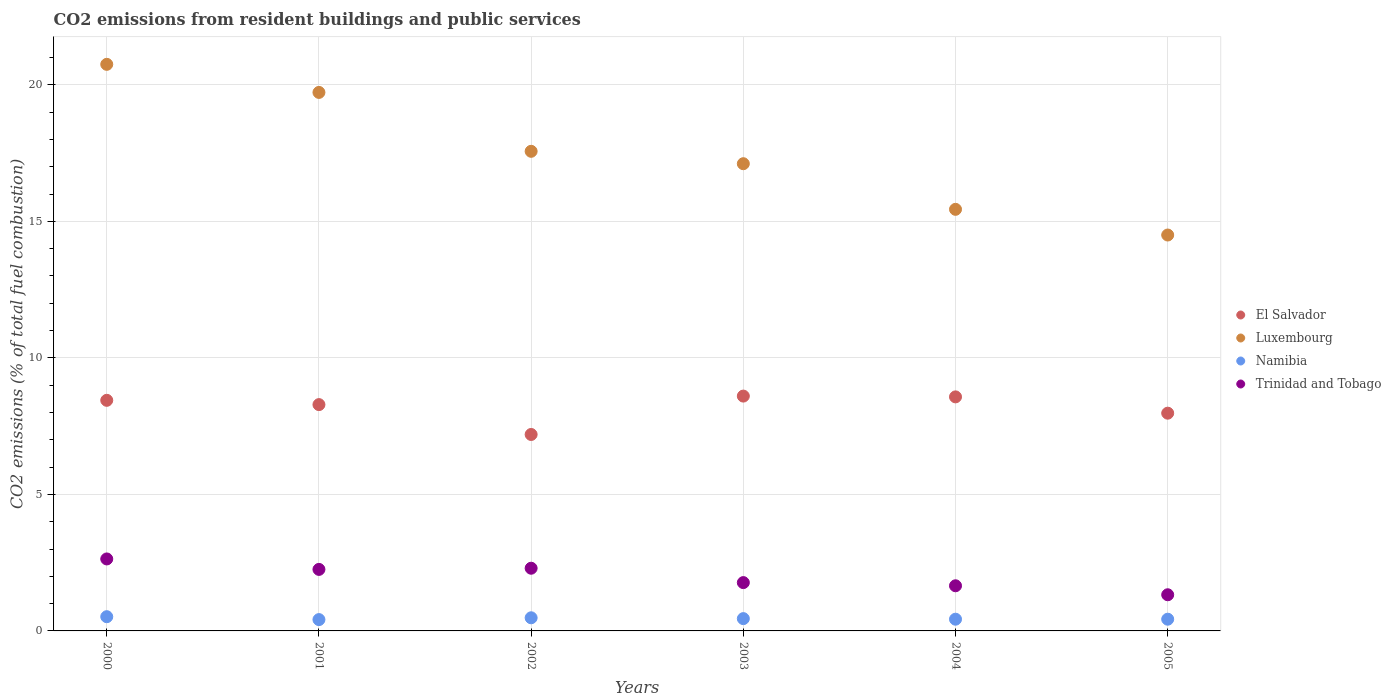How many different coloured dotlines are there?
Ensure brevity in your answer.  4. What is the total CO2 emitted in El Salvador in 2003?
Your answer should be compact. 8.6. Across all years, what is the maximum total CO2 emitted in Namibia?
Make the answer very short. 0.52. Across all years, what is the minimum total CO2 emitted in Luxembourg?
Offer a terse response. 14.5. In which year was the total CO2 emitted in Trinidad and Tobago maximum?
Your response must be concise. 2000. What is the total total CO2 emitted in El Salvador in the graph?
Provide a succinct answer. 49.07. What is the difference between the total CO2 emitted in Namibia in 2001 and that in 2002?
Offer a very short reply. -0.07. What is the difference between the total CO2 emitted in El Salvador in 2004 and the total CO2 emitted in Namibia in 2001?
Your answer should be compact. 8.16. What is the average total CO2 emitted in Trinidad and Tobago per year?
Ensure brevity in your answer.  1.99. In the year 2005, what is the difference between the total CO2 emitted in Trinidad and Tobago and total CO2 emitted in Luxembourg?
Offer a very short reply. -13.17. What is the ratio of the total CO2 emitted in Trinidad and Tobago in 2004 to that in 2005?
Your answer should be very brief. 1.25. Is the total CO2 emitted in El Salvador in 2000 less than that in 2004?
Provide a succinct answer. Yes. What is the difference between the highest and the second highest total CO2 emitted in Namibia?
Your answer should be very brief. 0.04. What is the difference between the highest and the lowest total CO2 emitted in Namibia?
Ensure brevity in your answer.  0.11. Is the sum of the total CO2 emitted in Trinidad and Tobago in 2000 and 2001 greater than the maximum total CO2 emitted in El Salvador across all years?
Keep it short and to the point. No. Is the total CO2 emitted in Namibia strictly greater than the total CO2 emitted in El Salvador over the years?
Make the answer very short. No. How many dotlines are there?
Provide a short and direct response. 4. What is the difference between two consecutive major ticks on the Y-axis?
Provide a short and direct response. 5. Where does the legend appear in the graph?
Ensure brevity in your answer.  Center right. How are the legend labels stacked?
Keep it short and to the point. Vertical. What is the title of the graph?
Ensure brevity in your answer.  CO2 emissions from resident buildings and public services. What is the label or title of the X-axis?
Provide a short and direct response. Years. What is the label or title of the Y-axis?
Your response must be concise. CO2 emissions (% of total fuel combustion). What is the CO2 emissions (% of total fuel combustion) of El Salvador in 2000?
Provide a succinct answer. 8.45. What is the CO2 emissions (% of total fuel combustion) in Luxembourg in 2000?
Your response must be concise. 20.75. What is the CO2 emissions (% of total fuel combustion) in Namibia in 2000?
Give a very brief answer. 0.52. What is the CO2 emissions (% of total fuel combustion) in Trinidad and Tobago in 2000?
Your answer should be compact. 2.64. What is the CO2 emissions (% of total fuel combustion) in El Salvador in 2001?
Your response must be concise. 8.29. What is the CO2 emissions (% of total fuel combustion) of Luxembourg in 2001?
Your response must be concise. 19.72. What is the CO2 emissions (% of total fuel combustion) in Namibia in 2001?
Make the answer very short. 0.41. What is the CO2 emissions (% of total fuel combustion) in Trinidad and Tobago in 2001?
Your response must be concise. 2.25. What is the CO2 emissions (% of total fuel combustion) of El Salvador in 2002?
Offer a terse response. 7.19. What is the CO2 emissions (% of total fuel combustion) in Luxembourg in 2002?
Your answer should be compact. 17.56. What is the CO2 emissions (% of total fuel combustion) of Namibia in 2002?
Ensure brevity in your answer.  0.48. What is the CO2 emissions (% of total fuel combustion) in Trinidad and Tobago in 2002?
Give a very brief answer. 2.3. What is the CO2 emissions (% of total fuel combustion) in El Salvador in 2003?
Your answer should be compact. 8.6. What is the CO2 emissions (% of total fuel combustion) of Luxembourg in 2003?
Your response must be concise. 17.11. What is the CO2 emissions (% of total fuel combustion) in Namibia in 2003?
Provide a short and direct response. 0.45. What is the CO2 emissions (% of total fuel combustion) of Trinidad and Tobago in 2003?
Provide a succinct answer. 1.77. What is the CO2 emissions (% of total fuel combustion) of El Salvador in 2004?
Your answer should be compact. 8.57. What is the CO2 emissions (% of total fuel combustion) of Luxembourg in 2004?
Make the answer very short. 15.44. What is the CO2 emissions (% of total fuel combustion) of Namibia in 2004?
Provide a short and direct response. 0.43. What is the CO2 emissions (% of total fuel combustion) of Trinidad and Tobago in 2004?
Offer a very short reply. 1.65. What is the CO2 emissions (% of total fuel combustion) in El Salvador in 2005?
Ensure brevity in your answer.  7.97. What is the CO2 emissions (% of total fuel combustion) of Luxembourg in 2005?
Your response must be concise. 14.5. What is the CO2 emissions (% of total fuel combustion) of Namibia in 2005?
Provide a short and direct response. 0.43. What is the CO2 emissions (% of total fuel combustion) in Trinidad and Tobago in 2005?
Ensure brevity in your answer.  1.32. Across all years, what is the maximum CO2 emissions (% of total fuel combustion) in El Salvador?
Provide a succinct answer. 8.6. Across all years, what is the maximum CO2 emissions (% of total fuel combustion) of Luxembourg?
Make the answer very short. 20.75. Across all years, what is the maximum CO2 emissions (% of total fuel combustion) of Namibia?
Your response must be concise. 0.52. Across all years, what is the maximum CO2 emissions (% of total fuel combustion) in Trinidad and Tobago?
Keep it short and to the point. 2.64. Across all years, what is the minimum CO2 emissions (% of total fuel combustion) of El Salvador?
Your response must be concise. 7.19. Across all years, what is the minimum CO2 emissions (% of total fuel combustion) of Luxembourg?
Your response must be concise. 14.5. Across all years, what is the minimum CO2 emissions (% of total fuel combustion) in Namibia?
Provide a succinct answer. 0.41. Across all years, what is the minimum CO2 emissions (% of total fuel combustion) in Trinidad and Tobago?
Give a very brief answer. 1.32. What is the total CO2 emissions (% of total fuel combustion) of El Salvador in the graph?
Ensure brevity in your answer.  49.07. What is the total CO2 emissions (% of total fuel combustion) in Luxembourg in the graph?
Offer a very short reply. 105.09. What is the total CO2 emissions (% of total fuel combustion) of Namibia in the graph?
Ensure brevity in your answer.  2.73. What is the total CO2 emissions (% of total fuel combustion) of Trinidad and Tobago in the graph?
Give a very brief answer. 11.93. What is the difference between the CO2 emissions (% of total fuel combustion) in El Salvador in 2000 and that in 2001?
Your answer should be very brief. 0.16. What is the difference between the CO2 emissions (% of total fuel combustion) of Luxembourg in 2000 and that in 2001?
Your response must be concise. 1.03. What is the difference between the CO2 emissions (% of total fuel combustion) of Namibia in 2000 and that in 2001?
Ensure brevity in your answer.  0.11. What is the difference between the CO2 emissions (% of total fuel combustion) in Trinidad and Tobago in 2000 and that in 2001?
Your answer should be very brief. 0.38. What is the difference between the CO2 emissions (% of total fuel combustion) in El Salvador in 2000 and that in 2002?
Your answer should be compact. 1.25. What is the difference between the CO2 emissions (% of total fuel combustion) of Luxembourg in 2000 and that in 2002?
Keep it short and to the point. 3.19. What is the difference between the CO2 emissions (% of total fuel combustion) in Namibia in 2000 and that in 2002?
Your response must be concise. 0.04. What is the difference between the CO2 emissions (% of total fuel combustion) in Trinidad and Tobago in 2000 and that in 2002?
Offer a terse response. 0.34. What is the difference between the CO2 emissions (% of total fuel combustion) of El Salvador in 2000 and that in 2003?
Your answer should be compact. -0.15. What is the difference between the CO2 emissions (% of total fuel combustion) in Luxembourg in 2000 and that in 2003?
Offer a very short reply. 3.64. What is the difference between the CO2 emissions (% of total fuel combustion) of Namibia in 2000 and that in 2003?
Offer a very short reply. 0.07. What is the difference between the CO2 emissions (% of total fuel combustion) in Trinidad and Tobago in 2000 and that in 2003?
Give a very brief answer. 0.87. What is the difference between the CO2 emissions (% of total fuel combustion) of El Salvador in 2000 and that in 2004?
Your response must be concise. -0.13. What is the difference between the CO2 emissions (% of total fuel combustion) in Luxembourg in 2000 and that in 2004?
Keep it short and to the point. 5.31. What is the difference between the CO2 emissions (% of total fuel combustion) in Namibia in 2000 and that in 2004?
Your response must be concise. 0.09. What is the difference between the CO2 emissions (% of total fuel combustion) in Trinidad and Tobago in 2000 and that in 2004?
Offer a terse response. 0.98. What is the difference between the CO2 emissions (% of total fuel combustion) of El Salvador in 2000 and that in 2005?
Offer a very short reply. 0.47. What is the difference between the CO2 emissions (% of total fuel combustion) in Luxembourg in 2000 and that in 2005?
Keep it short and to the point. 6.25. What is the difference between the CO2 emissions (% of total fuel combustion) of Namibia in 2000 and that in 2005?
Give a very brief answer. 0.09. What is the difference between the CO2 emissions (% of total fuel combustion) in Trinidad and Tobago in 2000 and that in 2005?
Provide a succinct answer. 1.31. What is the difference between the CO2 emissions (% of total fuel combustion) of El Salvador in 2001 and that in 2002?
Provide a short and direct response. 1.09. What is the difference between the CO2 emissions (% of total fuel combustion) in Luxembourg in 2001 and that in 2002?
Give a very brief answer. 2.16. What is the difference between the CO2 emissions (% of total fuel combustion) of Namibia in 2001 and that in 2002?
Give a very brief answer. -0.07. What is the difference between the CO2 emissions (% of total fuel combustion) of Trinidad and Tobago in 2001 and that in 2002?
Provide a succinct answer. -0.04. What is the difference between the CO2 emissions (% of total fuel combustion) of El Salvador in 2001 and that in 2003?
Give a very brief answer. -0.31. What is the difference between the CO2 emissions (% of total fuel combustion) in Luxembourg in 2001 and that in 2003?
Provide a succinct answer. 2.61. What is the difference between the CO2 emissions (% of total fuel combustion) of Namibia in 2001 and that in 2003?
Make the answer very short. -0.04. What is the difference between the CO2 emissions (% of total fuel combustion) of Trinidad and Tobago in 2001 and that in 2003?
Keep it short and to the point. 0.48. What is the difference between the CO2 emissions (% of total fuel combustion) in El Salvador in 2001 and that in 2004?
Your answer should be compact. -0.28. What is the difference between the CO2 emissions (% of total fuel combustion) in Luxembourg in 2001 and that in 2004?
Offer a terse response. 4.28. What is the difference between the CO2 emissions (% of total fuel combustion) of Namibia in 2001 and that in 2004?
Your answer should be compact. -0.01. What is the difference between the CO2 emissions (% of total fuel combustion) of Trinidad and Tobago in 2001 and that in 2004?
Keep it short and to the point. 0.6. What is the difference between the CO2 emissions (% of total fuel combustion) of El Salvador in 2001 and that in 2005?
Your answer should be compact. 0.31. What is the difference between the CO2 emissions (% of total fuel combustion) in Luxembourg in 2001 and that in 2005?
Provide a short and direct response. 5.22. What is the difference between the CO2 emissions (% of total fuel combustion) in Namibia in 2001 and that in 2005?
Offer a very short reply. -0.01. What is the difference between the CO2 emissions (% of total fuel combustion) of Trinidad and Tobago in 2001 and that in 2005?
Keep it short and to the point. 0.93. What is the difference between the CO2 emissions (% of total fuel combustion) of El Salvador in 2002 and that in 2003?
Offer a terse response. -1.41. What is the difference between the CO2 emissions (% of total fuel combustion) of Luxembourg in 2002 and that in 2003?
Make the answer very short. 0.45. What is the difference between the CO2 emissions (% of total fuel combustion) of Namibia in 2002 and that in 2003?
Make the answer very short. 0.03. What is the difference between the CO2 emissions (% of total fuel combustion) in Trinidad and Tobago in 2002 and that in 2003?
Your answer should be compact. 0.53. What is the difference between the CO2 emissions (% of total fuel combustion) of El Salvador in 2002 and that in 2004?
Make the answer very short. -1.38. What is the difference between the CO2 emissions (% of total fuel combustion) of Luxembourg in 2002 and that in 2004?
Make the answer very short. 2.12. What is the difference between the CO2 emissions (% of total fuel combustion) in Namibia in 2002 and that in 2004?
Your response must be concise. 0.05. What is the difference between the CO2 emissions (% of total fuel combustion) of Trinidad and Tobago in 2002 and that in 2004?
Keep it short and to the point. 0.64. What is the difference between the CO2 emissions (% of total fuel combustion) in El Salvador in 2002 and that in 2005?
Offer a terse response. -0.78. What is the difference between the CO2 emissions (% of total fuel combustion) in Luxembourg in 2002 and that in 2005?
Provide a succinct answer. 3.07. What is the difference between the CO2 emissions (% of total fuel combustion) of Namibia in 2002 and that in 2005?
Ensure brevity in your answer.  0.05. What is the difference between the CO2 emissions (% of total fuel combustion) of Trinidad and Tobago in 2002 and that in 2005?
Give a very brief answer. 0.97. What is the difference between the CO2 emissions (% of total fuel combustion) in El Salvador in 2003 and that in 2004?
Provide a short and direct response. 0.03. What is the difference between the CO2 emissions (% of total fuel combustion) of Luxembourg in 2003 and that in 2004?
Give a very brief answer. 1.67. What is the difference between the CO2 emissions (% of total fuel combustion) in Namibia in 2003 and that in 2004?
Provide a succinct answer. 0.02. What is the difference between the CO2 emissions (% of total fuel combustion) of Trinidad and Tobago in 2003 and that in 2004?
Your answer should be very brief. 0.12. What is the difference between the CO2 emissions (% of total fuel combustion) in El Salvador in 2003 and that in 2005?
Give a very brief answer. 0.63. What is the difference between the CO2 emissions (% of total fuel combustion) of Luxembourg in 2003 and that in 2005?
Provide a short and direct response. 2.61. What is the difference between the CO2 emissions (% of total fuel combustion) in Namibia in 2003 and that in 2005?
Make the answer very short. 0.02. What is the difference between the CO2 emissions (% of total fuel combustion) in Trinidad and Tobago in 2003 and that in 2005?
Your response must be concise. 0.45. What is the difference between the CO2 emissions (% of total fuel combustion) in El Salvador in 2004 and that in 2005?
Offer a very short reply. 0.6. What is the difference between the CO2 emissions (% of total fuel combustion) in Luxembourg in 2004 and that in 2005?
Your response must be concise. 0.94. What is the difference between the CO2 emissions (% of total fuel combustion) in Namibia in 2004 and that in 2005?
Give a very brief answer. 0. What is the difference between the CO2 emissions (% of total fuel combustion) in Trinidad and Tobago in 2004 and that in 2005?
Provide a short and direct response. 0.33. What is the difference between the CO2 emissions (% of total fuel combustion) in El Salvador in 2000 and the CO2 emissions (% of total fuel combustion) in Luxembourg in 2001?
Your answer should be very brief. -11.28. What is the difference between the CO2 emissions (% of total fuel combustion) of El Salvador in 2000 and the CO2 emissions (% of total fuel combustion) of Namibia in 2001?
Ensure brevity in your answer.  8.03. What is the difference between the CO2 emissions (% of total fuel combustion) in El Salvador in 2000 and the CO2 emissions (% of total fuel combustion) in Trinidad and Tobago in 2001?
Give a very brief answer. 6.19. What is the difference between the CO2 emissions (% of total fuel combustion) in Luxembourg in 2000 and the CO2 emissions (% of total fuel combustion) in Namibia in 2001?
Provide a short and direct response. 20.34. What is the difference between the CO2 emissions (% of total fuel combustion) in Luxembourg in 2000 and the CO2 emissions (% of total fuel combustion) in Trinidad and Tobago in 2001?
Provide a succinct answer. 18.5. What is the difference between the CO2 emissions (% of total fuel combustion) of Namibia in 2000 and the CO2 emissions (% of total fuel combustion) of Trinidad and Tobago in 2001?
Your answer should be compact. -1.73. What is the difference between the CO2 emissions (% of total fuel combustion) of El Salvador in 2000 and the CO2 emissions (% of total fuel combustion) of Luxembourg in 2002?
Provide a succinct answer. -9.12. What is the difference between the CO2 emissions (% of total fuel combustion) of El Salvador in 2000 and the CO2 emissions (% of total fuel combustion) of Namibia in 2002?
Your answer should be very brief. 7.96. What is the difference between the CO2 emissions (% of total fuel combustion) in El Salvador in 2000 and the CO2 emissions (% of total fuel combustion) in Trinidad and Tobago in 2002?
Make the answer very short. 6.15. What is the difference between the CO2 emissions (% of total fuel combustion) in Luxembourg in 2000 and the CO2 emissions (% of total fuel combustion) in Namibia in 2002?
Make the answer very short. 20.27. What is the difference between the CO2 emissions (% of total fuel combustion) of Luxembourg in 2000 and the CO2 emissions (% of total fuel combustion) of Trinidad and Tobago in 2002?
Make the answer very short. 18.45. What is the difference between the CO2 emissions (% of total fuel combustion) in Namibia in 2000 and the CO2 emissions (% of total fuel combustion) in Trinidad and Tobago in 2002?
Offer a very short reply. -1.77. What is the difference between the CO2 emissions (% of total fuel combustion) in El Salvador in 2000 and the CO2 emissions (% of total fuel combustion) in Luxembourg in 2003?
Provide a succinct answer. -8.67. What is the difference between the CO2 emissions (% of total fuel combustion) of El Salvador in 2000 and the CO2 emissions (% of total fuel combustion) of Namibia in 2003?
Offer a terse response. 7.99. What is the difference between the CO2 emissions (% of total fuel combustion) of El Salvador in 2000 and the CO2 emissions (% of total fuel combustion) of Trinidad and Tobago in 2003?
Provide a short and direct response. 6.68. What is the difference between the CO2 emissions (% of total fuel combustion) of Luxembourg in 2000 and the CO2 emissions (% of total fuel combustion) of Namibia in 2003?
Make the answer very short. 20.3. What is the difference between the CO2 emissions (% of total fuel combustion) of Luxembourg in 2000 and the CO2 emissions (% of total fuel combustion) of Trinidad and Tobago in 2003?
Ensure brevity in your answer.  18.98. What is the difference between the CO2 emissions (% of total fuel combustion) in Namibia in 2000 and the CO2 emissions (% of total fuel combustion) in Trinidad and Tobago in 2003?
Your answer should be compact. -1.25. What is the difference between the CO2 emissions (% of total fuel combustion) in El Salvador in 2000 and the CO2 emissions (% of total fuel combustion) in Luxembourg in 2004?
Ensure brevity in your answer.  -6.99. What is the difference between the CO2 emissions (% of total fuel combustion) of El Salvador in 2000 and the CO2 emissions (% of total fuel combustion) of Namibia in 2004?
Your answer should be compact. 8.02. What is the difference between the CO2 emissions (% of total fuel combustion) of El Salvador in 2000 and the CO2 emissions (% of total fuel combustion) of Trinidad and Tobago in 2004?
Keep it short and to the point. 6.79. What is the difference between the CO2 emissions (% of total fuel combustion) of Luxembourg in 2000 and the CO2 emissions (% of total fuel combustion) of Namibia in 2004?
Your response must be concise. 20.32. What is the difference between the CO2 emissions (% of total fuel combustion) of Luxembourg in 2000 and the CO2 emissions (% of total fuel combustion) of Trinidad and Tobago in 2004?
Offer a very short reply. 19.1. What is the difference between the CO2 emissions (% of total fuel combustion) of Namibia in 2000 and the CO2 emissions (% of total fuel combustion) of Trinidad and Tobago in 2004?
Offer a terse response. -1.13. What is the difference between the CO2 emissions (% of total fuel combustion) of El Salvador in 2000 and the CO2 emissions (% of total fuel combustion) of Luxembourg in 2005?
Offer a very short reply. -6.05. What is the difference between the CO2 emissions (% of total fuel combustion) in El Salvador in 2000 and the CO2 emissions (% of total fuel combustion) in Namibia in 2005?
Give a very brief answer. 8.02. What is the difference between the CO2 emissions (% of total fuel combustion) of El Salvador in 2000 and the CO2 emissions (% of total fuel combustion) of Trinidad and Tobago in 2005?
Give a very brief answer. 7.12. What is the difference between the CO2 emissions (% of total fuel combustion) of Luxembourg in 2000 and the CO2 emissions (% of total fuel combustion) of Namibia in 2005?
Provide a short and direct response. 20.32. What is the difference between the CO2 emissions (% of total fuel combustion) of Luxembourg in 2000 and the CO2 emissions (% of total fuel combustion) of Trinidad and Tobago in 2005?
Your response must be concise. 19.43. What is the difference between the CO2 emissions (% of total fuel combustion) in Namibia in 2000 and the CO2 emissions (% of total fuel combustion) in Trinidad and Tobago in 2005?
Your answer should be compact. -0.8. What is the difference between the CO2 emissions (% of total fuel combustion) of El Salvador in 2001 and the CO2 emissions (% of total fuel combustion) of Luxembourg in 2002?
Offer a very short reply. -9.28. What is the difference between the CO2 emissions (% of total fuel combustion) in El Salvador in 2001 and the CO2 emissions (% of total fuel combustion) in Namibia in 2002?
Give a very brief answer. 7.81. What is the difference between the CO2 emissions (% of total fuel combustion) in El Salvador in 2001 and the CO2 emissions (% of total fuel combustion) in Trinidad and Tobago in 2002?
Ensure brevity in your answer.  5.99. What is the difference between the CO2 emissions (% of total fuel combustion) of Luxembourg in 2001 and the CO2 emissions (% of total fuel combustion) of Namibia in 2002?
Ensure brevity in your answer.  19.24. What is the difference between the CO2 emissions (% of total fuel combustion) of Luxembourg in 2001 and the CO2 emissions (% of total fuel combustion) of Trinidad and Tobago in 2002?
Make the answer very short. 17.43. What is the difference between the CO2 emissions (% of total fuel combustion) of Namibia in 2001 and the CO2 emissions (% of total fuel combustion) of Trinidad and Tobago in 2002?
Keep it short and to the point. -1.88. What is the difference between the CO2 emissions (% of total fuel combustion) in El Salvador in 2001 and the CO2 emissions (% of total fuel combustion) in Luxembourg in 2003?
Offer a very short reply. -8.82. What is the difference between the CO2 emissions (% of total fuel combustion) in El Salvador in 2001 and the CO2 emissions (% of total fuel combustion) in Namibia in 2003?
Offer a terse response. 7.84. What is the difference between the CO2 emissions (% of total fuel combustion) of El Salvador in 2001 and the CO2 emissions (% of total fuel combustion) of Trinidad and Tobago in 2003?
Offer a very short reply. 6.52. What is the difference between the CO2 emissions (% of total fuel combustion) in Luxembourg in 2001 and the CO2 emissions (% of total fuel combustion) in Namibia in 2003?
Your response must be concise. 19.27. What is the difference between the CO2 emissions (% of total fuel combustion) of Luxembourg in 2001 and the CO2 emissions (% of total fuel combustion) of Trinidad and Tobago in 2003?
Offer a terse response. 17.95. What is the difference between the CO2 emissions (% of total fuel combustion) of Namibia in 2001 and the CO2 emissions (% of total fuel combustion) of Trinidad and Tobago in 2003?
Offer a very short reply. -1.35. What is the difference between the CO2 emissions (% of total fuel combustion) in El Salvador in 2001 and the CO2 emissions (% of total fuel combustion) in Luxembourg in 2004?
Ensure brevity in your answer.  -7.15. What is the difference between the CO2 emissions (% of total fuel combustion) in El Salvador in 2001 and the CO2 emissions (% of total fuel combustion) in Namibia in 2004?
Provide a succinct answer. 7.86. What is the difference between the CO2 emissions (% of total fuel combustion) of El Salvador in 2001 and the CO2 emissions (% of total fuel combustion) of Trinidad and Tobago in 2004?
Offer a very short reply. 6.64. What is the difference between the CO2 emissions (% of total fuel combustion) of Luxembourg in 2001 and the CO2 emissions (% of total fuel combustion) of Namibia in 2004?
Provide a succinct answer. 19.29. What is the difference between the CO2 emissions (% of total fuel combustion) in Luxembourg in 2001 and the CO2 emissions (% of total fuel combustion) in Trinidad and Tobago in 2004?
Your answer should be compact. 18.07. What is the difference between the CO2 emissions (% of total fuel combustion) in Namibia in 2001 and the CO2 emissions (% of total fuel combustion) in Trinidad and Tobago in 2004?
Provide a succinct answer. -1.24. What is the difference between the CO2 emissions (% of total fuel combustion) of El Salvador in 2001 and the CO2 emissions (% of total fuel combustion) of Luxembourg in 2005?
Give a very brief answer. -6.21. What is the difference between the CO2 emissions (% of total fuel combustion) of El Salvador in 2001 and the CO2 emissions (% of total fuel combustion) of Namibia in 2005?
Your answer should be very brief. 7.86. What is the difference between the CO2 emissions (% of total fuel combustion) of El Salvador in 2001 and the CO2 emissions (% of total fuel combustion) of Trinidad and Tobago in 2005?
Provide a succinct answer. 6.96. What is the difference between the CO2 emissions (% of total fuel combustion) of Luxembourg in 2001 and the CO2 emissions (% of total fuel combustion) of Namibia in 2005?
Your answer should be very brief. 19.29. What is the difference between the CO2 emissions (% of total fuel combustion) in Luxembourg in 2001 and the CO2 emissions (% of total fuel combustion) in Trinidad and Tobago in 2005?
Offer a terse response. 18.4. What is the difference between the CO2 emissions (% of total fuel combustion) of Namibia in 2001 and the CO2 emissions (% of total fuel combustion) of Trinidad and Tobago in 2005?
Ensure brevity in your answer.  -0.91. What is the difference between the CO2 emissions (% of total fuel combustion) of El Salvador in 2002 and the CO2 emissions (% of total fuel combustion) of Luxembourg in 2003?
Offer a terse response. -9.92. What is the difference between the CO2 emissions (% of total fuel combustion) of El Salvador in 2002 and the CO2 emissions (% of total fuel combustion) of Namibia in 2003?
Keep it short and to the point. 6.74. What is the difference between the CO2 emissions (% of total fuel combustion) of El Salvador in 2002 and the CO2 emissions (% of total fuel combustion) of Trinidad and Tobago in 2003?
Your answer should be compact. 5.42. What is the difference between the CO2 emissions (% of total fuel combustion) of Luxembourg in 2002 and the CO2 emissions (% of total fuel combustion) of Namibia in 2003?
Offer a terse response. 17.11. What is the difference between the CO2 emissions (% of total fuel combustion) of Luxembourg in 2002 and the CO2 emissions (% of total fuel combustion) of Trinidad and Tobago in 2003?
Your answer should be very brief. 15.8. What is the difference between the CO2 emissions (% of total fuel combustion) in Namibia in 2002 and the CO2 emissions (% of total fuel combustion) in Trinidad and Tobago in 2003?
Offer a very short reply. -1.29. What is the difference between the CO2 emissions (% of total fuel combustion) of El Salvador in 2002 and the CO2 emissions (% of total fuel combustion) of Luxembourg in 2004?
Your response must be concise. -8.25. What is the difference between the CO2 emissions (% of total fuel combustion) in El Salvador in 2002 and the CO2 emissions (% of total fuel combustion) in Namibia in 2004?
Make the answer very short. 6.77. What is the difference between the CO2 emissions (% of total fuel combustion) in El Salvador in 2002 and the CO2 emissions (% of total fuel combustion) in Trinidad and Tobago in 2004?
Offer a very short reply. 5.54. What is the difference between the CO2 emissions (% of total fuel combustion) in Luxembourg in 2002 and the CO2 emissions (% of total fuel combustion) in Namibia in 2004?
Ensure brevity in your answer.  17.14. What is the difference between the CO2 emissions (% of total fuel combustion) in Luxembourg in 2002 and the CO2 emissions (% of total fuel combustion) in Trinidad and Tobago in 2004?
Your answer should be very brief. 15.91. What is the difference between the CO2 emissions (% of total fuel combustion) in Namibia in 2002 and the CO2 emissions (% of total fuel combustion) in Trinidad and Tobago in 2004?
Your answer should be compact. -1.17. What is the difference between the CO2 emissions (% of total fuel combustion) in El Salvador in 2002 and the CO2 emissions (% of total fuel combustion) in Luxembourg in 2005?
Provide a short and direct response. -7.3. What is the difference between the CO2 emissions (% of total fuel combustion) in El Salvador in 2002 and the CO2 emissions (% of total fuel combustion) in Namibia in 2005?
Your response must be concise. 6.77. What is the difference between the CO2 emissions (% of total fuel combustion) of El Salvador in 2002 and the CO2 emissions (% of total fuel combustion) of Trinidad and Tobago in 2005?
Provide a succinct answer. 5.87. What is the difference between the CO2 emissions (% of total fuel combustion) in Luxembourg in 2002 and the CO2 emissions (% of total fuel combustion) in Namibia in 2005?
Give a very brief answer. 17.14. What is the difference between the CO2 emissions (% of total fuel combustion) in Luxembourg in 2002 and the CO2 emissions (% of total fuel combustion) in Trinidad and Tobago in 2005?
Your answer should be compact. 16.24. What is the difference between the CO2 emissions (% of total fuel combustion) in Namibia in 2002 and the CO2 emissions (% of total fuel combustion) in Trinidad and Tobago in 2005?
Provide a short and direct response. -0.84. What is the difference between the CO2 emissions (% of total fuel combustion) in El Salvador in 2003 and the CO2 emissions (% of total fuel combustion) in Luxembourg in 2004?
Your answer should be very brief. -6.84. What is the difference between the CO2 emissions (% of total fuel combustion) in El Salvador in 2003 and the CO2 emissions (% of total fuel combustion) in Namibia in 2004?
Your answer should be compact. 8.17. What is the difference between the CO2 emissions (% of total fuel combustion) in El Salvador in 2003 and the CO2 emissions (% of total fuel combustion) in Trinidad and Tobago in 2004?
Your response must be concise. 6.95. What is the difference between the CO2 emissions (% of total fuel combustion) in Luxembourg in 2003 and the CO2 emissions (% of total fuel combustion) in Namibia in 2004?
Provide a short and direct response. 16.68. What is the difference between the CO2 emissions (% of total fuel combustion) in Luxembourg in 2003 and the CO2 emissions (% of total fuel combustion) in Trinidad and Tobago in 2004?
Your response must be concise. 15.46. What is the difference between the CO2 emissions (% of total fuel combustion) of Namibia in 2003 and the CO2 emissions (% of total fuel combustion) of Trinidad and Tobago in 2004?
Your answer should be compact. -1.2. What is the difference between the CO2 emissions (% of total fuel combustion) in El Salvador in 2003 and the CO2 emissions (% of total fuel combustion) in Luxembourg in 2005?
Your answer should be very brief. -5.9. What is the difference between the CO2 emissions (% of total fuel combustion) in El Salvador in 2003 and the CO2 emissions (% of total fuel combustion) in Namibia in 2005?
Provide a short and direct response. 8.17. What is the difference between the CO2 emissions (% of total fuel combustion) in El Salvador in 2003 and the CO2 emissions (% of total fuel combustion) in Trinidad and Tobago in 2005?
Your answer should be very brief. 7.28. What is the difference between the CO2 emissions (% of total fuel combustion) of Luxembourg in 2003 and the CO2 emissions (% of total fuel combustion) of Namibia in 2005?
Your response must be concise. 16.68. What is the difference between the CO2 emissions (% of total fuel combustion) in Luxembourg in 2003 and the CO2 emissions (% of total fuel combustion) in Trinidad and Tobago in 2005?
Ensure brevity in your answer.  15.79. What is the difference between the CO2 emissions (% of total fuel combustion) of Namibia in 2003 and the CO2 emissions (% of total fuel combustion) of Trinidad and Tobago in 2005?
Keep it short and to the point. -0.87. What is the difference between the CO2 emissions (% of total fuel combustion) in El Salvador in 2004 and the CO2 emissions (% of total fuel combustion) in Luxembourg in 2005?
Provide a short and direct response. -5.93. What is the difference between the CO2 emissions (% of total fuel combustion) of El Salvador in 2004 and the CO2 emissions (% of total fuel combustion) of Namibia in 2005?
Give a very brief answer. 8.14. What is the difference between the CO2 emissions (% of total fuel combustion) in El Salvador in 2004 and the CO2 emissions (% of total fuel combustion) in Trinidad and Tobago in 2005?
Offer a very short reply. 7.25. What is the difference between the CO2 emissions (% of total fuel combustion) in Luxembourg in 2004 and the CO2 emissions (% of total fuel combustion) in Namibia in 2005?
Offer a terse response. 15.01. What is the difference between the CO2 emissions (% of total fuel combustion) in Luxembourg in 2004 and the CO2 emissions (% of total fuel combustion) in Trinidad and Tobago in 2005?
Give a very brief answer. 14.12. What is the difference between the CO2 emissions (% of total fuel combustion) of Namibia in 2004 and the CO2 emissions (% of total fuel combustion) of Trinidad and Tobago in 2005?
Give a very brief answer. -0.9. What is the average CO2 emissions (% of total fuel combustion) of El Salvador per year?
Keep it short and to the point. 8.18. What is the average CO2 emissions (% of total fuel combustion) in Luxembourg per year?
Offer a very short reply. 17.51. What is the average CO2 emissions (% of total fuel combustion) of Namibia per year?
Ensure brevity in your answer.  0.45. What is the average CO2 emissions (% of total fuel combustion) in Trinidad and Tobago per year?
Your response must be concise. 1.99. In the year 2000, what is the difference between the CO2 emissions (% of total fuel combustion) in El Salvador and CO2 emissions (% of total fuel combustion) in Luxembourg?
Offer a terse response. -12.3. In the year 2000, what is the difference between the CO2 emissions (% of total fuel combustion) of El Salvador and CO2 emissions (% of total fuel combustion) of Namibia?
Ensure brevity in your answer.  7.92. In the year 2000, what is the difference between the CO2 emissions (% of total fuel combustion) of El Salvador and CO2 emissions (% of total fuel combustion) of Trinidad and Tobago?
Ensure brevity in your answer.  5.81. In the year 2000, what is the difference between the CO2 emissions (% of total fuel combustion) of Luxembourg and CO2 emissions (% of total fuel combustion) of Namibia?
Make the answer very short. 20.23. In the year 2000, what is the difference between the CO2 emissions (% of total fuel combustion) in Luxembourg and CO2 emissions (% of total fuel combustion) in Trinidad and Tobago?
Keep it short and to the point. 18.11. In the year 2000, what is the difference between the CO2 emissions (% of total fuel combustion) in Namibia and CO2 emissions (% of total fuel combustion) in Trinidad and Tobago?
Offer a very short reply. -2.12. In the year 2001, what is the difference between the CO2 emissions (% of total fuel combustion) in El Salvador and CO2 emissions (% of total fuel combustion) in Luxembourg?
Your answer should be compact. -11.43. In the year 2001, what is the difference between the CO2 emissions (% of total fuel combustion) in El Salvador and CO2 emissions (% of total fuel combustion) in Namibia?
Your response must be concise. 7.87. In the year 2001, what is the difference between the CO2 emissions (% of total fuel combustion) in El Salvador and CO2 emissions (% of total fuel combustion) in Trinidad and Tobago?
Make the answer very short. 6.04. In the year 2001, what is the difference between the CO2 emissions (% of total fuel combustion) of Luxembourg and CO2 emissions (% of total fuel combustion) of Namibia?
Ensure brevity in your answer.  19.31. In the year 2001, what is the difference between the CO2 emissions (% of total fuel combustion) in Luxembourg and CO2 emissions (% of total fuel combustion) in Trinidad and Tobago?
Your answer should be very brief. 17.47. In the year 2001, what is the difference between the CO2 emissions (% of total fuel combustion) in Namibia and CO2 emissions (% of total fuel combustion) in Trinidad and Tobago?
Give a very brief answer. -1.84. In the year 2002, what is the difference between the CO2 emissions (% of total fuel combustion) of El Salvador and CO2 emissions (% of total fuel combustion) of Luxembourg?
Ensure brevity in your answer.  -10.37. In the year 2002, what is the difference between the CO2 emissions (% of total fuel combustion) of El Salvador and CO2 emissions (% of total fuel combustion) of Namibia?
Provide a short and direct response. 6.71. In the year 2002, what is the difference between the CO2 emissions (% of total fuel combustion) of El Salvador and CO2 emissions (% of total fuel combustion) of Trinidad and Tobago?
Keep it short and to the point. 4.9. In the year 2002, what is the difference between the CO2 emissions (% of total fuel combustion) in Luxembourg and CO2 emissions (% of total fuel combustion) in Namibia?
Keep it short and to the point. 17.08. In the year 2002, what is the difference between the CO2 emissions (% of total fuel combustion) in Luxembourg and CO2 emissions (% of total fuel combustion) in Trinidad and Tobago?
Your response must be concise. 15.27. In the year 2002, what is the difference between the CO2 emissions (% of total fuel combustion) in Namibia and CO2 emissions (% of total fuel combustion) in Trinidad and Tobago?
Your answer should be compact. -1.81. In the year 2003, what is the difference between the CO2 emissions (% of total fuel combustion) in El Salvador and CO2 emissions (% of total fuel combustion) in Luxembourg?
Your answer should be very brief. -8.51. In the year 2003, what is the difference between the CO2 emissions (% of total fuel combustion) of El Salvador and CO2 emissions (% of total fuel combustion) of Namibia?
Your answer should be very brief. 8.15. In the year 2003, what is the difference between the CO2 emissions (% of total fuel combustion) in El Salvador and CO2 emissions (% of total fuel combustion) in Trinidad and Tobago?
Make the answer very short. 6.83. In the year 2003, what is the difference between the CO2 emissions (% of total fuel combustion) in Luxembourg and CO2 emissions (% of total fuel combustion) in Namibia?
Provide a short and direct response. 16.66. In the year 2003, what is the difference between the CO2 emissions (% of total fuel combustion) of Luxembourg and CO2 emissions (% of total fuel combustion) of Trinidad and Tobago?
Your answer should be very brief. 15.34. In the year 2003, what is the difference between the CO2 emissions (% of total fuel combustion) of Namibia and CO2 emissions (% of total fuel combustion) of Trinidad and Tobago?
Keep it short and to the point. -1.32. In the year 2004, what is the difference between the CO2 emissions (% of total fuel combustion) in El Salvador and CO2 emissions (% of total fuel combustion) in Luxembourg?
Provide a succinct answer. -6.87. In the year 2004, what is the difference between the CO2 emissions (% of total fuel combustion) of El Salvador and CO2 emissions (% of total fuel combustion) of Namibia?
Give a very brief answer. 8.14. In the year 2004, what is the difference between the CO2 emissions (% of total fuel combustion) of El Salvador and CO2 emissions (% of total fuel combustion) of Trinidad and Tobago?
Provide a short and direct response. 6.92. In the year 2004, what is the difference between the CO2 emissions (% of total fuel combustion) in Luxembourg and CO2 emissions (% of total fuel combustion) in Namibia?
Offer a very short reply. 15.01. In the year 2004, what is the difference between the CO2 emissions (% of total fuel combustion) in Luxembourg and CO2 emissions (% of total fuel combustion) in Trinidad and Tobago?
Your answer should be compact. 13.79. In the year 2004, what is the difference between the CO2 emissions (% of total fuel combustion) in Namibia and CO2 emissions (% of total fuel combustion) in Trinidad and Tobago?
Your answer should be very brief. -1.22. In the year 2005, what is the difference between the CO2 emissions (% of total fuel combustion) in El Salvador and CO2 emissions (% of total fuel combustion) in Luxembourg?
Keep it short and to the point. -6.52. In the year 2005, what is the difference between the CO2 emissions (% of total fuel combustion) in El Salvador and CO2 emissions (% of total fuel combustion) in Namibia?
Provide a short and direct response. 7.55. In the year 2005, what is the difference between the CO2 emissions (% of total fuel combustion) of El Salvador and CO2 emissions (% of total fuel combustion) of Trinidad and Tobago?
Give a very brief answer. 6.65. In the year 2005, what is the difference between the CO2 emissions (% of total fuel combustion) of Luxembourg and CO2 emissions (% of total fuel combustion) of Namibia?
Make the answer very short. 14.07. In the year 2005, what is the difference between the CO2 emissions (% of total fuel combustion) in Luxembourg and CO2 emissions (% of total fuel combustion) in Trinidad and Tobago?
Your answer should be compact. 13.17. In the year 2005, what is the difference between the CO2 emissions (% of total fuel combustion) in Namibia and CO2 emissions (% of total fuel combustion) in Trinidad and Tobago?
Keep it short and to the point. -0.9. What is the ratio of the CO2 emissions (% of total fuel combustion) in El Salvador in 2000 to that in 2001?
Give a very brief answer. 1.02. What is the ratio of the CO2 emissions (% of total fuel combustion) in Luxembourg in 2000 to that in 2001?
Offer a terse response. 1.05. What is the ratio of the CO2 emissions (% of total fuel combustion) of Namibia in 2000 to that in 2001?
Your answer should be compact. 1.26. What is the ratio of the CO2 emissions (% of total fuel combustion) in Trinidad and Tobago in 2000 to that in 2001?
Your answer should be compact. 1.17. What is the ratio of the CO2 emissions (% of total fuel combustion) of El Salvador in 2000 to that in 2002?
Make the answer very short. 1.17. What is the ratio of the CO2 emissions (% of total fuel combustion) of Luxembourg in 2000 to that in 2002?
Offer a terse response. 1.18. What is the ratio of the CO2 emissions (% of total fuel combustion) in Trinidad and Tobago in 2000 to that in 2002?
Make the answer very short. 1.15. What is the ratio of the CO2 emissions (% of total fuel combustion) in El Salvador in 2000 to that in 2003?
Offer a terse response. 0.98. What is the ratio of the CO2 emissions (% of total fuel combustion) of Luxembourg in 2000 to that in 2003?
Ensure brevity in your answer.  1.21. What is the ratio of the CO2 emissions (% of total fuel combustion) in Namibia in 2000 to that in 2003?
Make the answer very short. 1.16. What is the ratio of the CO2 emissions (% of total fuel combustion) of Trinidad and Tobago in 2000 to that in 2003?
Ensure brevity in your answer.  1.49. What is the ratio of the CO2 emissions (% of total fuel combustion) in El Salvador in 2000 to that in 2004?
Provide a short and direct response. 0.99. What is the ratio of the CO2 emissions (% of total fuel combustion) of Luxembourg in 2000 to that in 2004?
Your response must be concise. 1.34. What is the ratio of the CO2 emissions (% of total fuel combustion) in Namibia in 2000 to that in 2004?
Your answer should be compact. 1.21. What is the ratio of the CO2 emissions (% of total fuel combustion) of Trinidad and Tobago in 2000 to that in 2004?
Give a very brief answer. 1.59. What is the ratio of the CO2 emissions (% of total fuel combustion) of El Salvador in 2000 to that in 2005?
Your answer should be compact. 1.06. What is the ratio of the CO2 emissions (% of total fuel combustion) of Luxembourg in 2000 to that in 2005?
Offer a terse response. 1.43. What is the ratio of the CO2 emissions (% of total fuel combustion) of Namibia in 2000 to that in 2005?
Offer a very short reply. 1.21. What is the ratio of the CO2 emissions (% of total fuel combustion) of Trinidad and Tobago in 2000 to that in 2005?
Provide a short and direct response. 1.99. What is the ratio of the CO2 emissions (% of total fuel combustion) in El Salvador in 2001 to that in 2002?
Make the answer very short. 1.15. What is the ratio of the CO2 emissions (% of total fuel combustion) of Luxembourg in 2001 to that in 2002?
Offer a very short reply. 1.12. What is the ratio of the CO2 emissions (% of total fuel combustion) in Namibia in 2001 to that in 2002?
Keep it short and to the point. 0.86. What is the ratio of the CO2 emissions (% of total fuel combustion) in Trinidad and Tobago in 2001 to that in 2002?
Make the answer very short. 0.98. What is the ratio of the CO2 emissions (% of total fuel combustion) in El Salvador in 2001 to that in 2003?
Provide a succinct answer. 0.96. What is the ratio of the CO2 emissions (% of total fuel combustion) of Luxembourg in 2001 to that in 2003?
Your answer should be very brief. 1.15. What is the ratio of the CO2 emissions (% of total fuel combustion) of Namibia in 2001 to that in 2003?
Offer a terse response. 0.92. What is the ratio of the CO2 emissions (% of total fuel combustion) of Trinidad and Tobago in 2001 to that in 2003?
Make the answer very short. 1.27. What is the ratio of the CO2 emissions (% of total fuel combustion) in El Salvador in 2001 to that in 2004?
Keep it short and to the point. 0.97. What is the ratio of the CO2 emissions (% of total fuel combustion) of Luxembourg in 2001 to that in 2004?
Your answer should be very brief. 1.28. What is the ratio of the CO2 emissions (% of total fuel combustion) of Namibia in 2001 to that in 2004?
Ensure brevity in your answer.  0.97. What is the ratio of the CO2 emissions (% of total fuel combustion) of Trinidad and Tobago in 2001 to that in 2004?
Offer a very short reply. 1.36. What is the ratio of the CO2 emissions (% of total fuel combustion) of El Salvador in 2001 to that in 2005?
Your answer should be compact. 1.04. What is the ratio of the CO2 emissions (% of total fuel combustion) of Luxembourg in 2001 to that in 2005?
Provide a succinct answer. 1.36. What is the ratio of the CO2 emissions (% of total fuel combustion) in Namibia in 2001 to that in 2005?
Offer a very short reply. 0.97. What is the ratio of the CO2 emissions (% of total fuel combustion) in Trinidad and Tobago in 2001 to that in 2005?
Your response must be concise. 1.7. What is the ratio of the CO2 emissions (% of total fuel combustion) of El Salvador in 2002 to that in 2003?
Offer a very short reply. 0.84. What is the ratio of the CO2 emissions (% of total fuel combustion) of Luxembourg in 2002 to that in 2003?
Make the answer very short. 1.03. What is the ratio of the CO2 emissions (% of total fuel combustion) in Namibia in 2002 to that in 2003?
Your response must be concise. 1.07. What is the ratio of the CO2 emissions (% of total fuel combustion) of Trinidad and Tobago in 2002 to that in 2003?
Your answer should be compact. 1.3. What is the ratio of the CO2 emissions (% of total fuel combustion) of El Salvador in 2002 to that in 2004?
Provide a succinct answer. 0.84. What is the ratio of the CO2 emissions (% of total fuel combustion) of Luxembourg in 2002 to that in 2004?
Ensure brevity in your answer.  1.14. What is the ratio of the CO2 emissions (% of total fuel combustion) of Namibia in 2002 to that in 2004?
Provide a short and direct response. 1.12. What is the ratio of the CO2 emissions (% of total fuel combustion) of Trinidad and Tobago in 2002 to that in 2004?
Provide a short and direct response. 1.39. What is the ratio of the CO2 emissions (% of total fuel combustion) of El Salvador in 2002 to that in 2005?
Your response must be concise. 0.9. What is the ratio of the CO2 emissions (% of total fuel combustion) in Luxembourg in 2002 to that in 2005?
Offer a terse response. 1.21. What is the ratio of the CO2 emissions (% of total fuel combustion) of Namibia in 2002 to that in 2005?
Provide a succinct answer. 1.12. What is the ratio of the CO2 emissions (% of total fuel combustion) in Trinidad and Tobago in 2002 to that in 2005?
Give a very brief answer. 1.73. What is the ratio of the CO2 emissions (% of total fuel combustion) of El Salvador in 2003 to that in 2004?
Provide a succinct answer. 1. What is the ratio of the CO2 emissions (% of total fuel combustion) in Luxembourg in 2003 to that in 2004?
Give a very brief answer. 1.11. What is the ratio of the CO2 emissions (% of total fuel combustion) in Namibia in 2003 to that in 2004?
Your response must be concise. 1.05. What is the ratio of the CO2 emissions (% of total fuel combustion) in Trinidad and Tobago in 2003 to that in 2004?
Provide a succinct answer. 1.07. What is the ratio of the CO2 emissions (% of total fuel combustion) of El Salvador in 2003 to that in 2005?
Ensure brevity in your answer.  1.08. What is the ratio of the CO2 emissions (% of total fuel combustion) in Luxembourg in 2003 to that in 2005?
Your answer should be very brief. 1.18. What is the ratio of the CO2 emissions (% of total fuel combustion) in Namibia in 2003 to that in 2005?
Provide a short and direct response. 1.05. What is the ratio of the CO2 emissions (% of total fuel combustion) in Trinidad and Tobago in 2003 to that in 2005?
Keep it short and to the point. 1.34. What is the ratio of the CO2 emissions (% of total fuel combustion) of El Salvador in 2004 to that in 2005?
Provide a short and direct response. 1.07. What is the ratio of the CO2 emissions (% of total fuel combustion) of Luxembourg in 2004 to that in 2005?
Provide a succinct answer. 1.06. What is the ratio of the CO2 emissions (% of total fuel combustion) of Trinidad and Tobago in 2004 to that in 2005?
Your answer should be compact. 1.25. What is the difference between the highest and the second highest CO2 emissions (% of total fuel combustion) of El Salvador?
Your answer should be compact. 0.03. What is the difference between the highest and the second highest CO2 emissions (% of total fuel combustion) in Luxembourg?
Your answer should be very brief. 1.03. What is the difference between the highest and the second highest CO2 emissions (% of total fuel combustion) of Namibia?
Make the answer very short. 0.04. What is the difference between the highest and the second highest CO2 emissions (% of total fuel combustion) of Trinidad and Tobago?
Ensure brevity in your answer.  0.34. What is the difference between the highest and the lowest CO2 emissions (% of total fuel combustion) of El Salvador?
Your response must be concise. 1.41. What is the difference between the highest and the lowest CO2 emissions (% of total fuel combustion) in Luxembourg?
Your response must be concise. 6.25. What is the difference between the highest and the lowest CO2 emissions (% of total fuel combustion) of Namibia?
Provide a short and direct response. 0.11. What is the difference between the highest and the lowest CO2 emissions (% of total fuel combustion) of Trinidad and Tobago?
Your response must be concise. 1.31. 